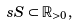<formula> <loc_0><loc_0><loc_500><loc_500>\ s S \subset \mathbb { R } _ { > 0 } ,</formula> 